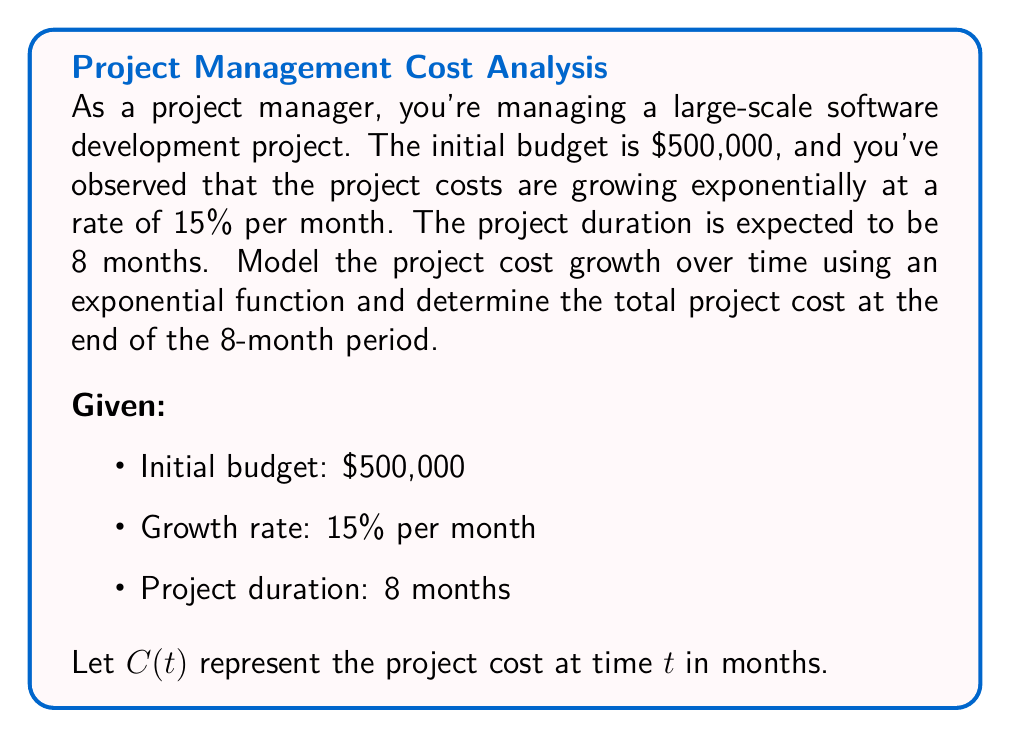Provide a solution to this math problem. To model the project cost growth over time using an exponential function, we'll follow these steps:

1) The general form of an exponential function is:
   $$C(t) = C_0 \cdot e^{rt}$$
   where $C_0$ is the initial cost, $r$ is the growth rate, and $t$ is time in months.

2) We know:
   $C_0 = 500,000$
   $r = 0.15$ (15% expressed as a decimal)
   We need to find $C(8)$

3) Plugging these values into our exponential function:
   $$C(t) = 500,000 \cdot e^{0.15t}$$

4) To find the cost at 8 months, we calculate $C(8)$:
   $$C(8) = 500,000 \cdot e^{0.15 \cdot 8}$$

5) Simplify:
   $$C(8) = 500,000 \cdot e^{1.2}$$

6) Calculate $e^{1.2}$ (you can use a calculator for this):
   $$e^{1.2} \approx 3.3201$$

7) Multiply:
   $$C(8) = 500,000 \cdot 3.3201 = 1,660,050$$

Therefore, the total project cost at the end of 8 months will be approximately $1,660,050.
Answer: $1,660,050 